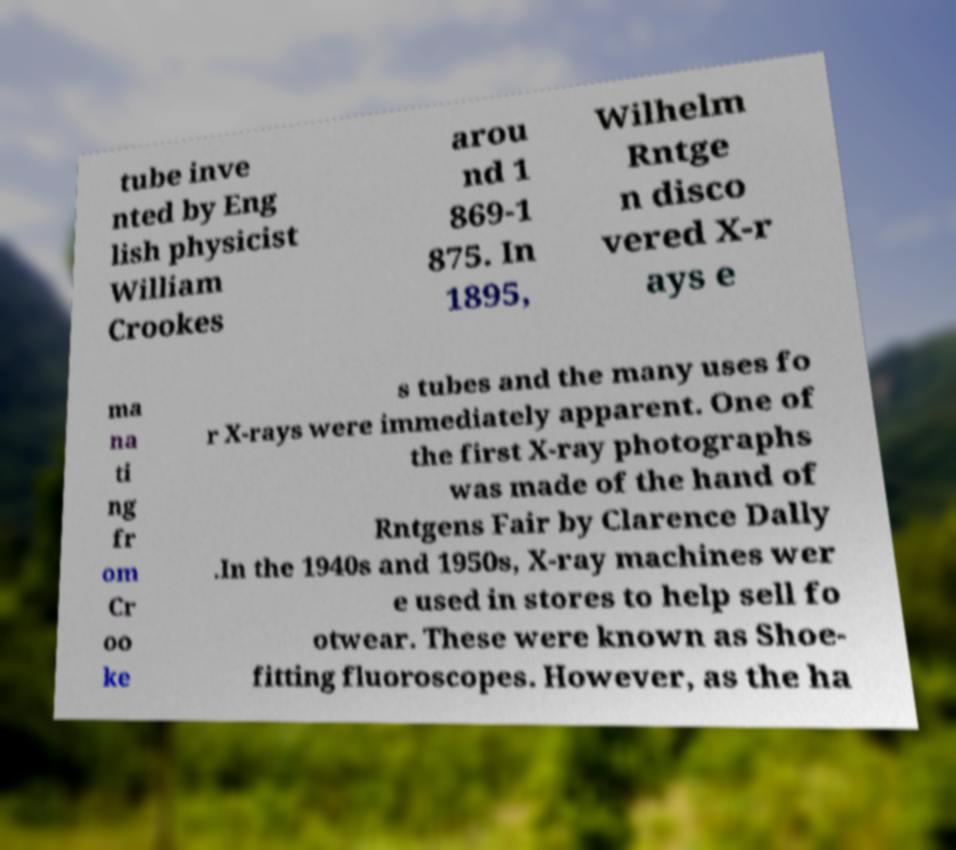For documentation purposes, I need the text within this image transcribed. Could you provide that? tube inve nted by Eng lish physicist William Crookes arou nd 1 869-1 875. In 1895, Wilhelm Rntge n disco vered X-r ays e ma na ti ng fr om Cr oo ke s tubes and the many uses fo r X-rays were immediately apparent. One of the first X-ray photographs was made of the hand of Rntgens Fair by Clarence Dally .In the 1940s and 1950s, X-ray machines wer e used in stores to help sell fo otwear. These were known as Shoe- fitting fluoroscopes. However, as the ha 